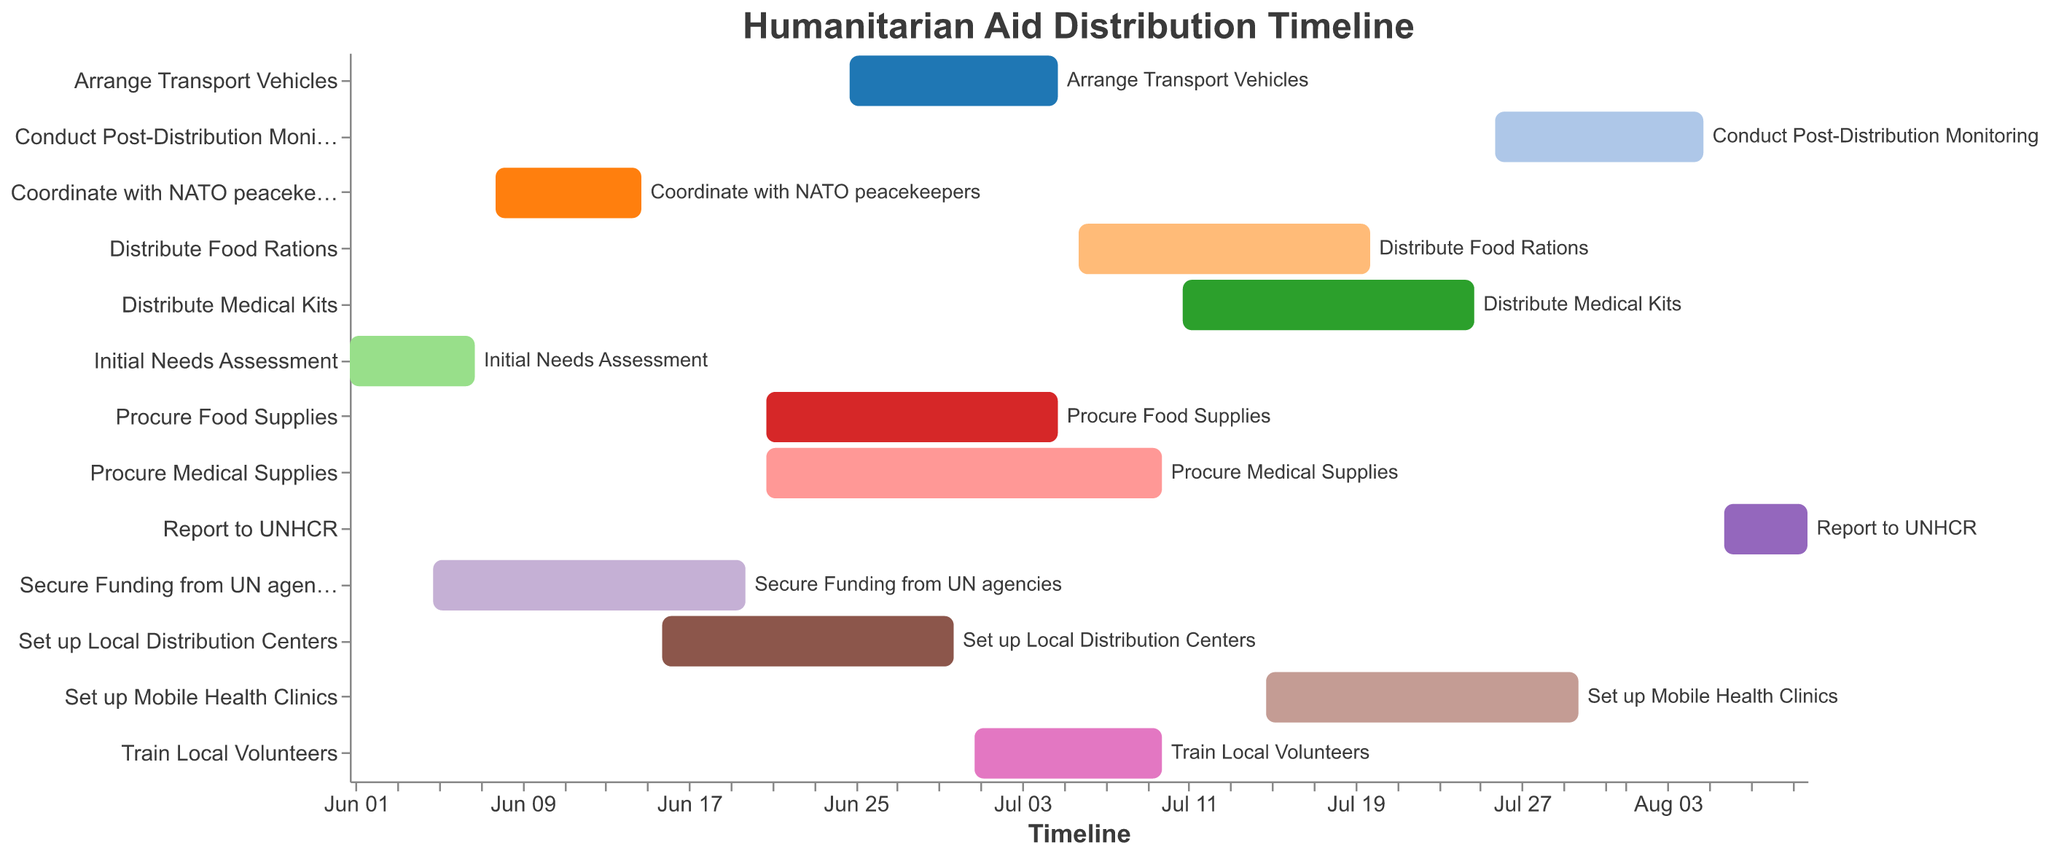Which task starts on June 25, 2023? Find the bar that corresponds to the start date of June 25, 2023.
Answer: Arrange Transport Vehicles What is the duration of the "Procure Medical Supplies" task? Calculate the difference between the start and end dates for the "Procure Medical Supplies" task.
Answer: 20 days Which task ends first, "Initial Needs Assessment" or "Coordinate with NATO peacekeepers"? Compare the end dates of both tasks to determine which finishes first.
Answer: Initial Needs Assessment Which tasks are carried out in parallel during the first week of July 2023? Identify tasks whose start and end dates overlap during the specified period.
Answer: Procure Medical Supplies, Arrange Transport Vehicles, Train Local Volunteers How long is the gap between the end of "Set up Local Distribution Centers" and the start of "Procure Food Supplies"? Calculate the number of days between the end of one task and the start of the next related task.
Answer: 6 days Which task has the same start date as "Procure Food Supplies"? Find another task that starts on June 21, 2023.
Answer: Procure Medical Supplies What is the start and end date for the "Distribute Medical Kits" task? Read the "Distribute Medical Kits" task's bar coordinates for start and end dates directly from the chart.
Answer: Start: July 11, 2023, End: July 25, 2023 Which task has the longest duration? Compare the durations (difference between start and end dates) of all tasks.
Answer: Procure Medical Supplies 